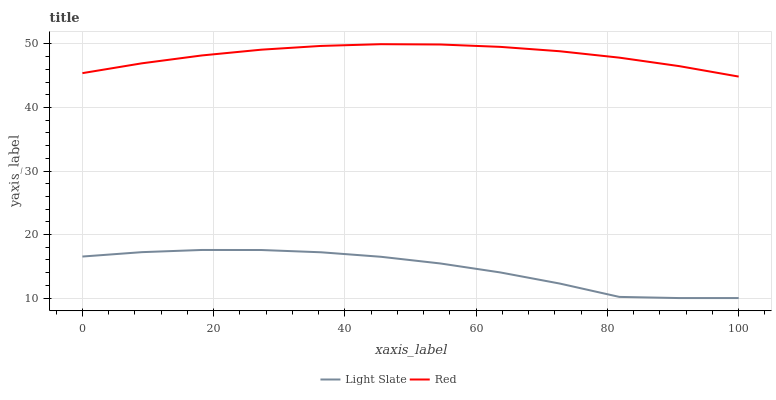Does Light Slate have the minimum area under the curve?
Answer yes or no. Yes. Does Red have the maximum area under the curve?
Answer yes or no. Yes. Does Red have the minimum area under the curve?
Answer yes or no. No. Is Red the smoothest?
Answer yes or no. Yes. Is Light Slate the roughest?
Answer yes or no. Yes. Is Red the roughest?
Answer yes or no. No. Does Light Slate have the lowest value?
Answer yes or no. Yes. Does Red have the lowest value?
Answer yes or no. No. Does Red have the highest value?
Answer yes or no. Yes. Is Light Slate less than Red?
Answer yes or no. Yes. Is Red greater than Light Slate?
Answer yes or no. Yes. Does Light Slate intersect Red?
Answer yes or no. No. 